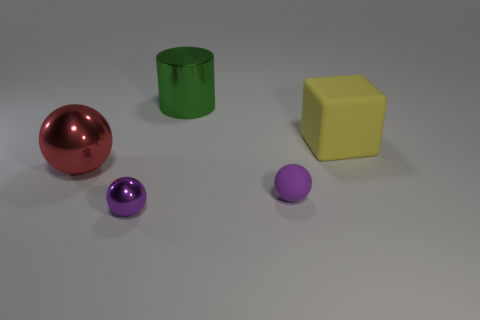What is the color of the ball that is made of the same material as the yellow block?
Give a very brief answer. Purple. Does the object that is behind the big yellow object have the same color as the tiny metal sphere?
Provide a succinct answer. No. How many spheres are large yellow rubber things or green things?
Ensure brevity in your answer.  0. How big is the matte thing that is behind the metallic object that is to the left of the small purple thing that is to the left of the purple matte object?
Provide a short and direct response. Large. The yellow rubber thing that is the same size as the green cylinder is what shape?
Your answer should be compact. Cube. The small shiny object is what shape?
Your response must be concise. Sphere. Are the large cylinder that is on the right side of the large red shiny sphere and the yellow thing made of the same material?
Your response must be concise. No. What size is the purple thing left of the small object to the right of the big green cylinder?
Offer a terse response. Small. There is a thing that is left of the green cylinder and in front of the red metallic ball; what is its color?
Your answer should be compact. Purple. There is a cylinder that is the same size as the red object; what is it made of?
Offer a terse response. Metal. 